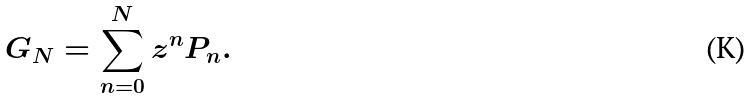<formula> <loc_0><loc_0><loc_500><loc_500>G _ { N } = \sum _ { n = 0 } ^ { N } z ^ { n } P _ { n } .</formula> 